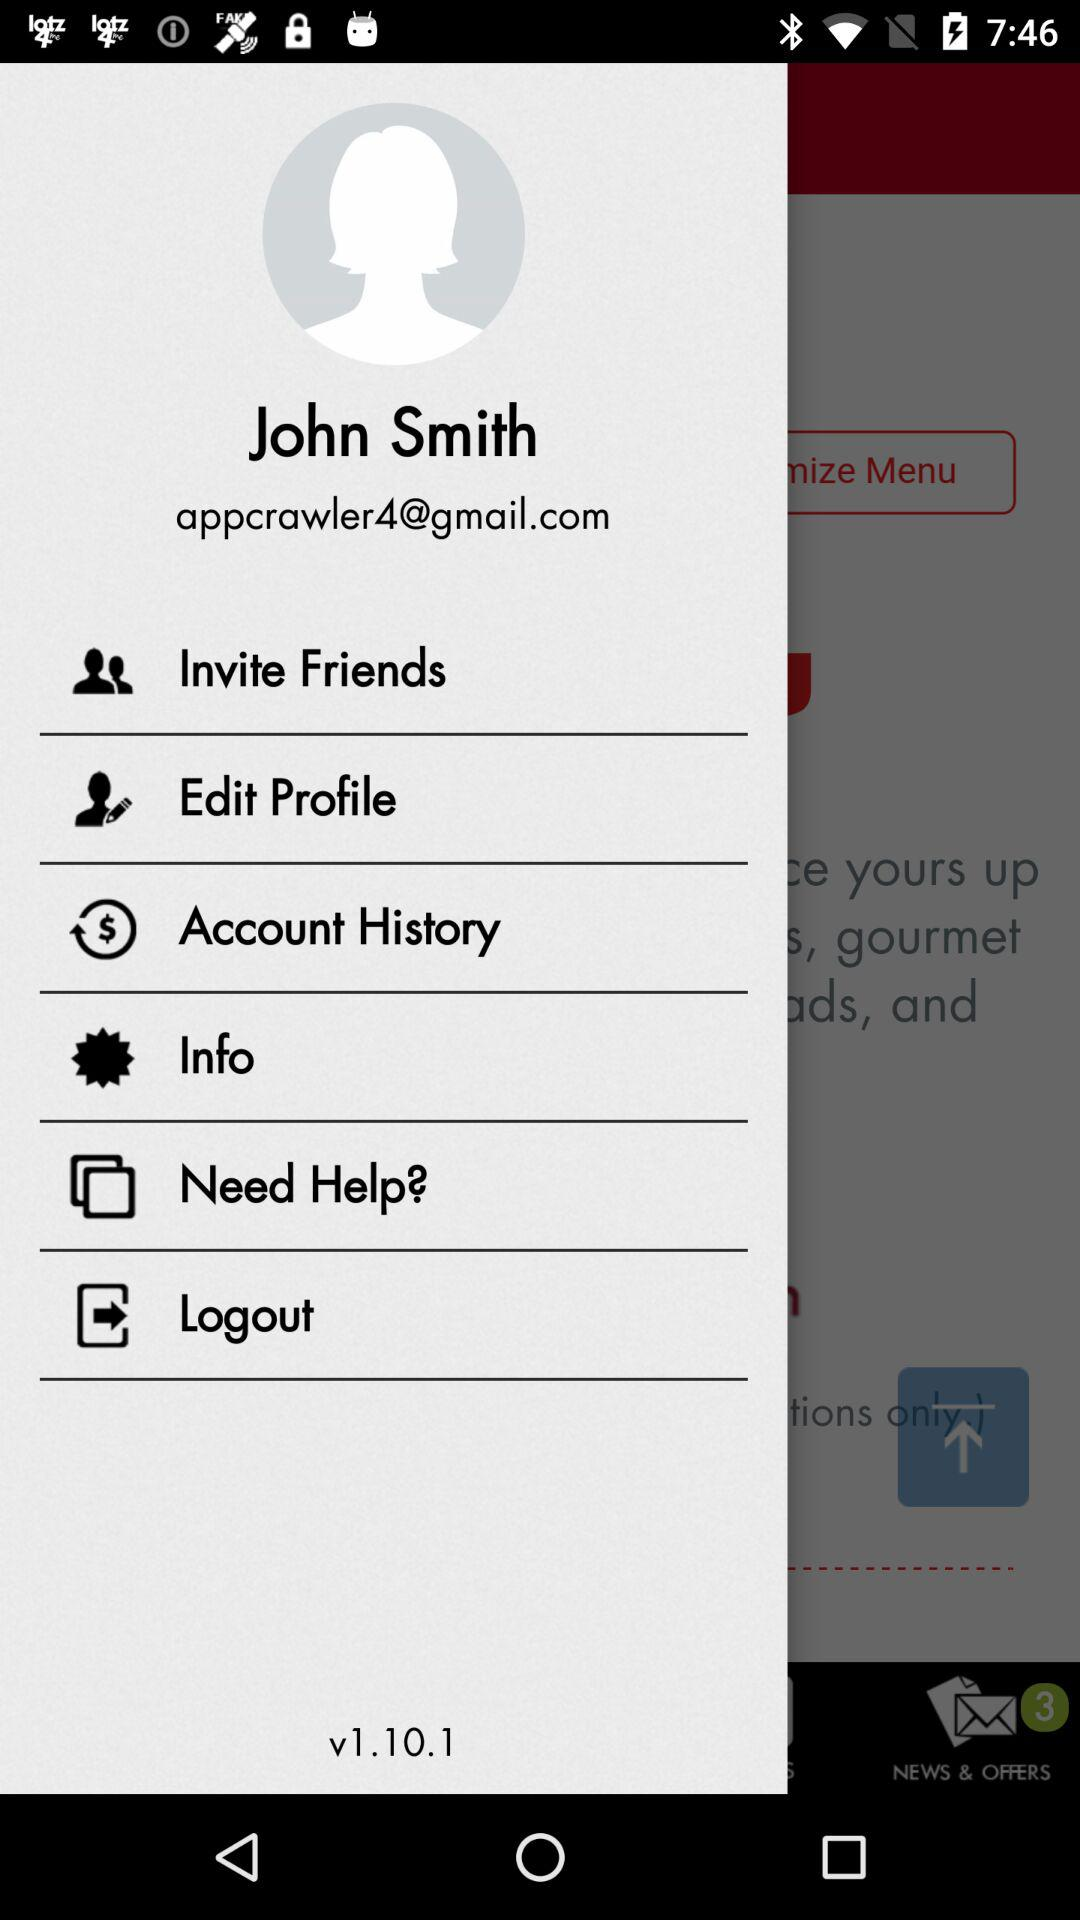What is the email address of the user? The email address of the user is appcrawler4@gmail.com. 